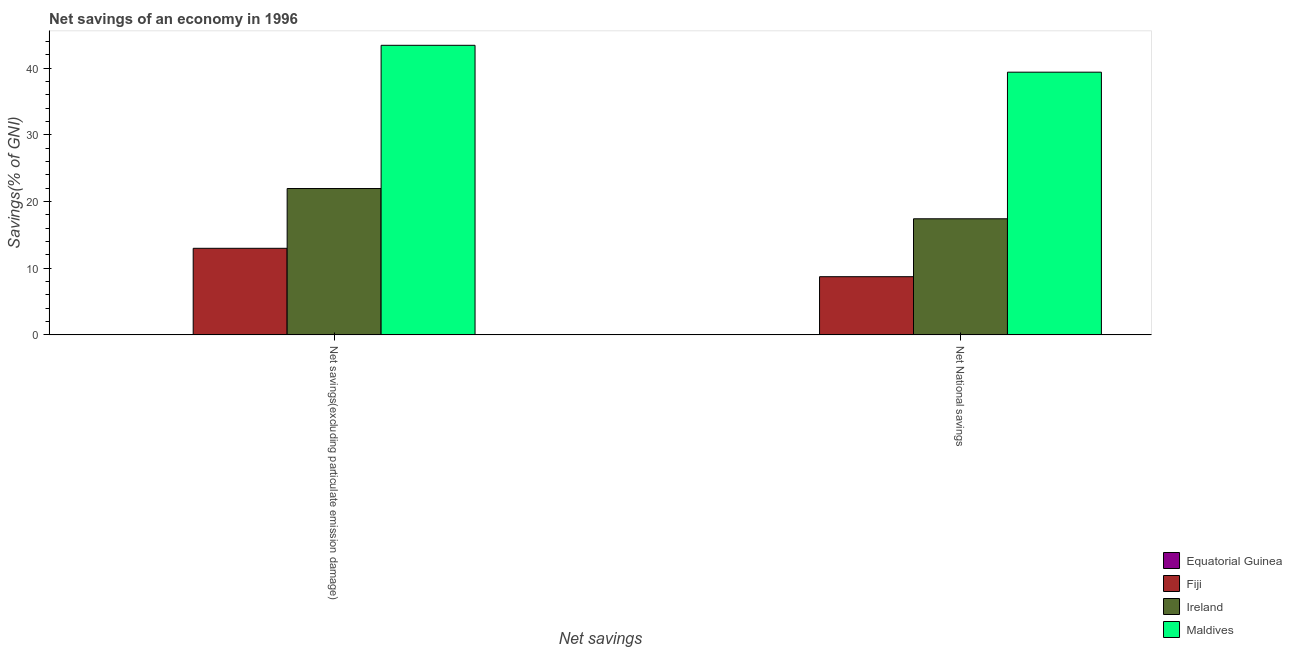Are the number of bars on each tick of the X-axis equal?
Your answer should be compact. Yes. What is the label of the 2nd group of bars from the left?
Ensure brevity in your answer.  Net National savings. What is the net savings(excluding particulate emission damage) in Equatorial Guinea?
Offer a very short reply. 0. Across all countries, what is the maximum net savings(excluding particulate emission damage)?
Make the answer very short. 43.4. In which country was the net national savings maximum?
Offer a very short reply. Maldives. What is the total net savings(excluding particulate emission damage) in the graph?
Your response must be concise. 78.32. What is the difference between the net savings(excluding particulate emission damage) in Maldives and that in Fiji?
Give a very brief answer. 30.43. What is the difference between the net national savings in Maldives and the net savings(excluding particulate emission damage) in Ireland?
Offer a terse response. 17.44. What is the average net national savings per country?
Give a very brief answer. 16.38. What is the difference between the net savings(excluding particulate emission damage) and net national savings in Ireland?
Your answer should be compact. 4.54. In how many countries, is the net savings(excluding particulate emission damage) greater than 14 %?
Make the answer very short. 2. What is the ratio of the net national savings in Maldives to that in Fiji?
Your response must be concise. 4.51. Is the net national savings in Maldives less than that in Fiji?
Offer a terse response. No. In how many countries, is the net savings(excluding particulate emission damage) greater than the average net savings(excluding particulate emission damage) taken over all countries?
Your answer should be compact. 2. Are the values on the major ticks of Y-axis written in scientific E-notation?
Offer a terse response. No. Does the graph contain any zero values?
Provide a short and direct response. Yes. Does the graph contain grids?
Ensure brevity in your answer.  No. What is the title of the graph?
Offer a very short reply. Net savings of an economy in 1996. Does "Georgia" appear as one of the legend labels in the graph?
Offer a terse response. No. What is the label or title of the X-axis?
Give a very brief answer. Net savings. What is the label or title of the Y-axis?
Provide a short and direct response. Savings(% of GNI). What is the Savings(% of GNI) of Equatorial Guinea in Net savings(excluding particulate emission damage)?
Keep it short and to the point. 0. What is the Savings(% of GNI) of Fiji in Net savings(excluding particulate emission damage)?
Make the answer very short. 12.98. What is the Savings(% of GNI) in Ireland in Net savings(excluding particulate emission damage)?
Your answer should be very brief. 21.94. What is the Savings(% of GNI) of Maldives in Net savings(excluding particulate emission damage)?
Offer a very short reply. 43.4. What is the Savings(% of GNI) in Fiji in Net National savings?
Make the answer very short. 8.72. What is the Savings(% of GNI) in Ireland in Net National savings?
Provide a short and direct response. 17.4. What is the Savings(% of GNI) of Maldives in Net National savings?
Ensure brevity in your answer.  39.38. Across all Net savings, what is the maximum Savings(% of GNI) of Fiji?
Make the answer very short. 12.98. Across all Net savings, what is the maximum Savings(% of GNI) in Ireland?
Provide a succinct answer. 21.94. Across all Net savings, what is the maximum Savings(% of GNI) in Maldives?
Provide a short and direct response. 43.4. Across all Net savings, what is the minimum Savings(% of GNI) of Fiji?
Offer a very short reply. 8.72. Across all Net savings, what is the minimum Savings(% of GNI) in Ireland?
Provide a short and direct response. 17.4. Across all Net savings, what is the minimum Savings(% of GNI) of Maldives?
Keep it short and to the point. 39.38. What is the total Savings(% of GNI) of Equatorial Guinea in the graph?
Ensure brevity in your answer.  0. What is the total Savings(% of GNI) in Fiji in the graph?
Offer a terse response. 21.7. What is the total Savings(% of GNI) of Ireland in the graph?
Your response must be concise. 39.34. What is the total Savings(% of GNI) of Maldives in the graph?
Your answer should be compact. 82.78. What is the difference between the Savings(% of GNI) in Fiji in Net savings(excluding particulate emission damage) and that in Net National savings?
Your answer should be compact. 4.25. What is the difference between the Savings(% of GNI) of Ireland in Net savings(excluding particulate emission damage) and that in Net National savings?
Offer a terse response. 4.54. What is the difference between the Savings(% of GNI) in Maldives in Net savings(excluding particulate emission damage) and that in Net National savings?
Ensure brevity in your answer.  4.03. What is the difference between the Savings(% of GNI) of Fiji in Net savings(excluding particulate emission damage) and the Savings(% of GNI) of Ireland in Net National savings?
Your answer should be very brief. -4.42. What is the difference between the Savings(% of GNI) in Fiji in Net savings(excluding particulate emission damage) and the Savings(% of GNI) in Maldives in Net National savings?
Offer a very short reply. -26.4. What is the difference between the Savings(% of GNI) of Ireland in Net savings(excluding particulate emission damage) and the Savings(% of GNI) of Maldives in Net National savings?
Ensure brevity in your answer.  -17.44. What is the average Savings(% of GNI) of Equatorial Guinea per Net savings?
Ensure brevity in your answer.  0. What is the average Savings(% of GNI) of Fiji per Net savings?
Provide a short and direct response. 10.85. What is the average Savings(% of GNI) in Ireland per Net savings?
Ensure brevity in your answer.  19.67. What is the average Savings(% of GNI) of Maldives per Net savings?
Offer a very short reply. 41.39. What is the difference between the Savings(% of GNI) of Fiji and Savings(% of GNI) of Ireland in Net savings(excluding particulate emission damage)?
Provide a succinct answer. -8.96. What is the difference between the Savings(% of GNI) in Fiji and Savings(% of GNI) in Maldives in Net savings(excluding particulate emission damage)?
Make the answer very short. -30.43. What is the difference between the Savings(% of GNI) of Ireland and Savings(% of GNI) of Maldives in Net savings(excluding particulate emission damage)?
Ensure brevity in your answer.  -21.47. What is the difference between the Savings(% of GNI) of Fiji and Savings(% of GNI) of Ireland in Net National savings?
Keep it short and to the point. -8.68. What is the difference between the Savings(% of GNI) of Fiji and Savings(% of GNI) of Maldives in Net National savings?
Keep it short and to the point. -30.65. What is the difference between the Savings(% of GNI) in Ireland and Savings(% of GNI) in Maldives in Net National savings?
Your answer should be very brief. -21.97. What is the ratio of the Savings(% of GNI) in Fiji in Net savings(excluding particulate emission damage) to that in Net National savings?
Give a very brief answer. 1.49. What is the ratio of the Savings(% of GNI) in Ireland in Net savings(excluding particulate emission damage) to that in Net National savings?
Make the answer very short. 1.26. What is the ratio of the Savings(% of GNI) in Maldives in Net savings(excluding particulate emission damage) to that in Net National savings?
Make the answer very short. 1.1. What is the difference between the highest and the second highest Savings(% of GNI) in Fiji?
Keep it short and to the point. 4.25. What is the difference between the highest and the second highest Savings(% of GNI) in Ireland?
Your answer should be very brief. 4.54. What is the difference between the highest and the second highest Savings(% of GNI) in Maldives?
Offer a very short reply. 4.03. What is the difference between the highest and the lowest Savings(% of GNI) in Fiji?
Your answer should be very brief. 4.25. What is the difference between the highest and the lowest Savings(% of GNI) in Ireland?
Your response must be concise. 4.54. What is the difference between the highest and the lowest Savings(% of GNI) in Maldives?
Your response must be concise. 4.03. 